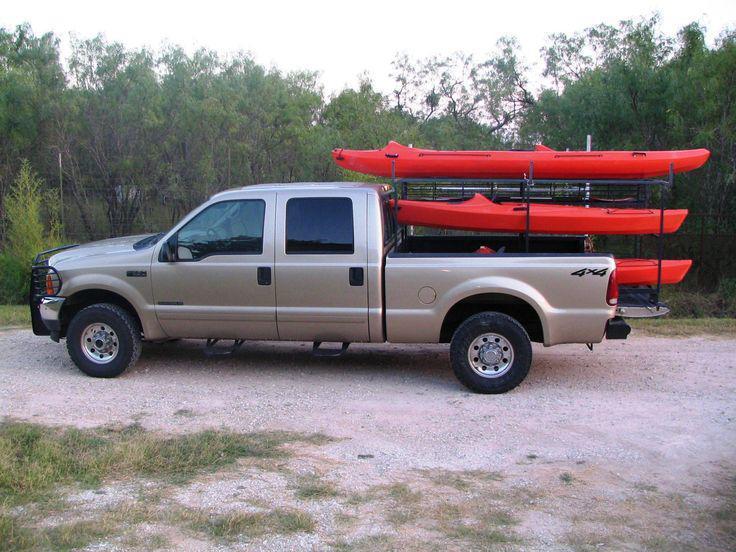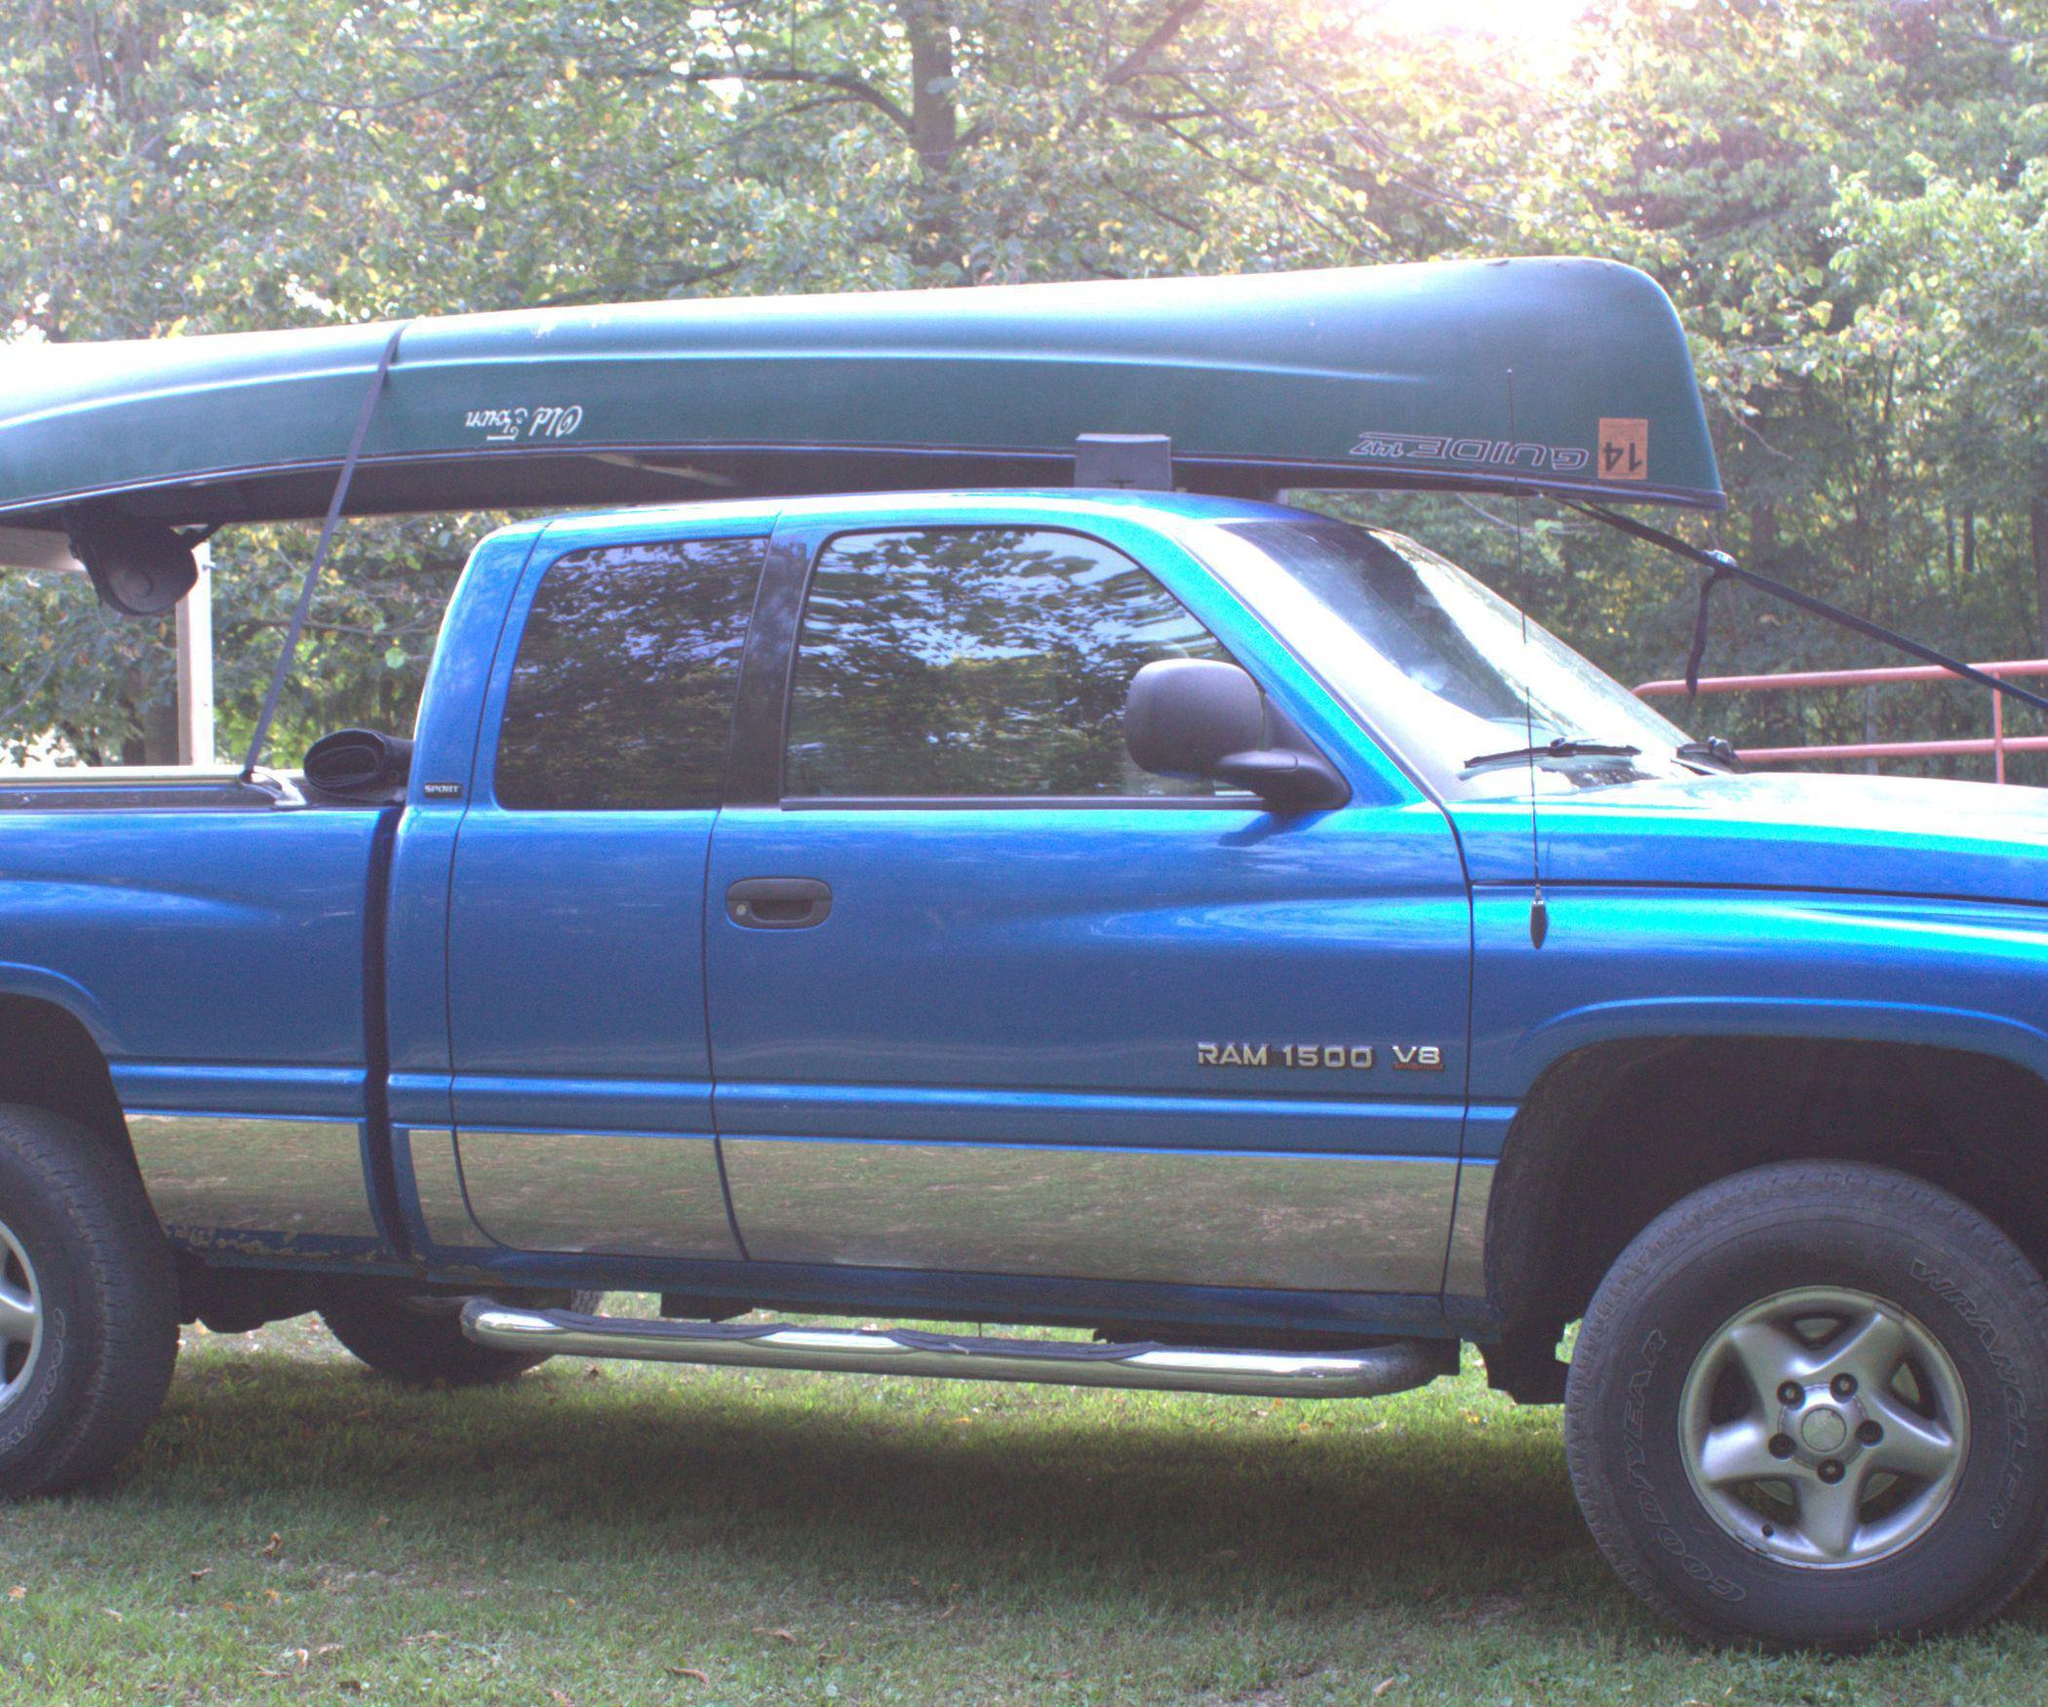The first image is the image on the left, the second image is the image on the right. Analyze the images presented: Is the assertion "A vehicle in one image is loaded with more than one boat." valid? Answer yes or no. Yes. 